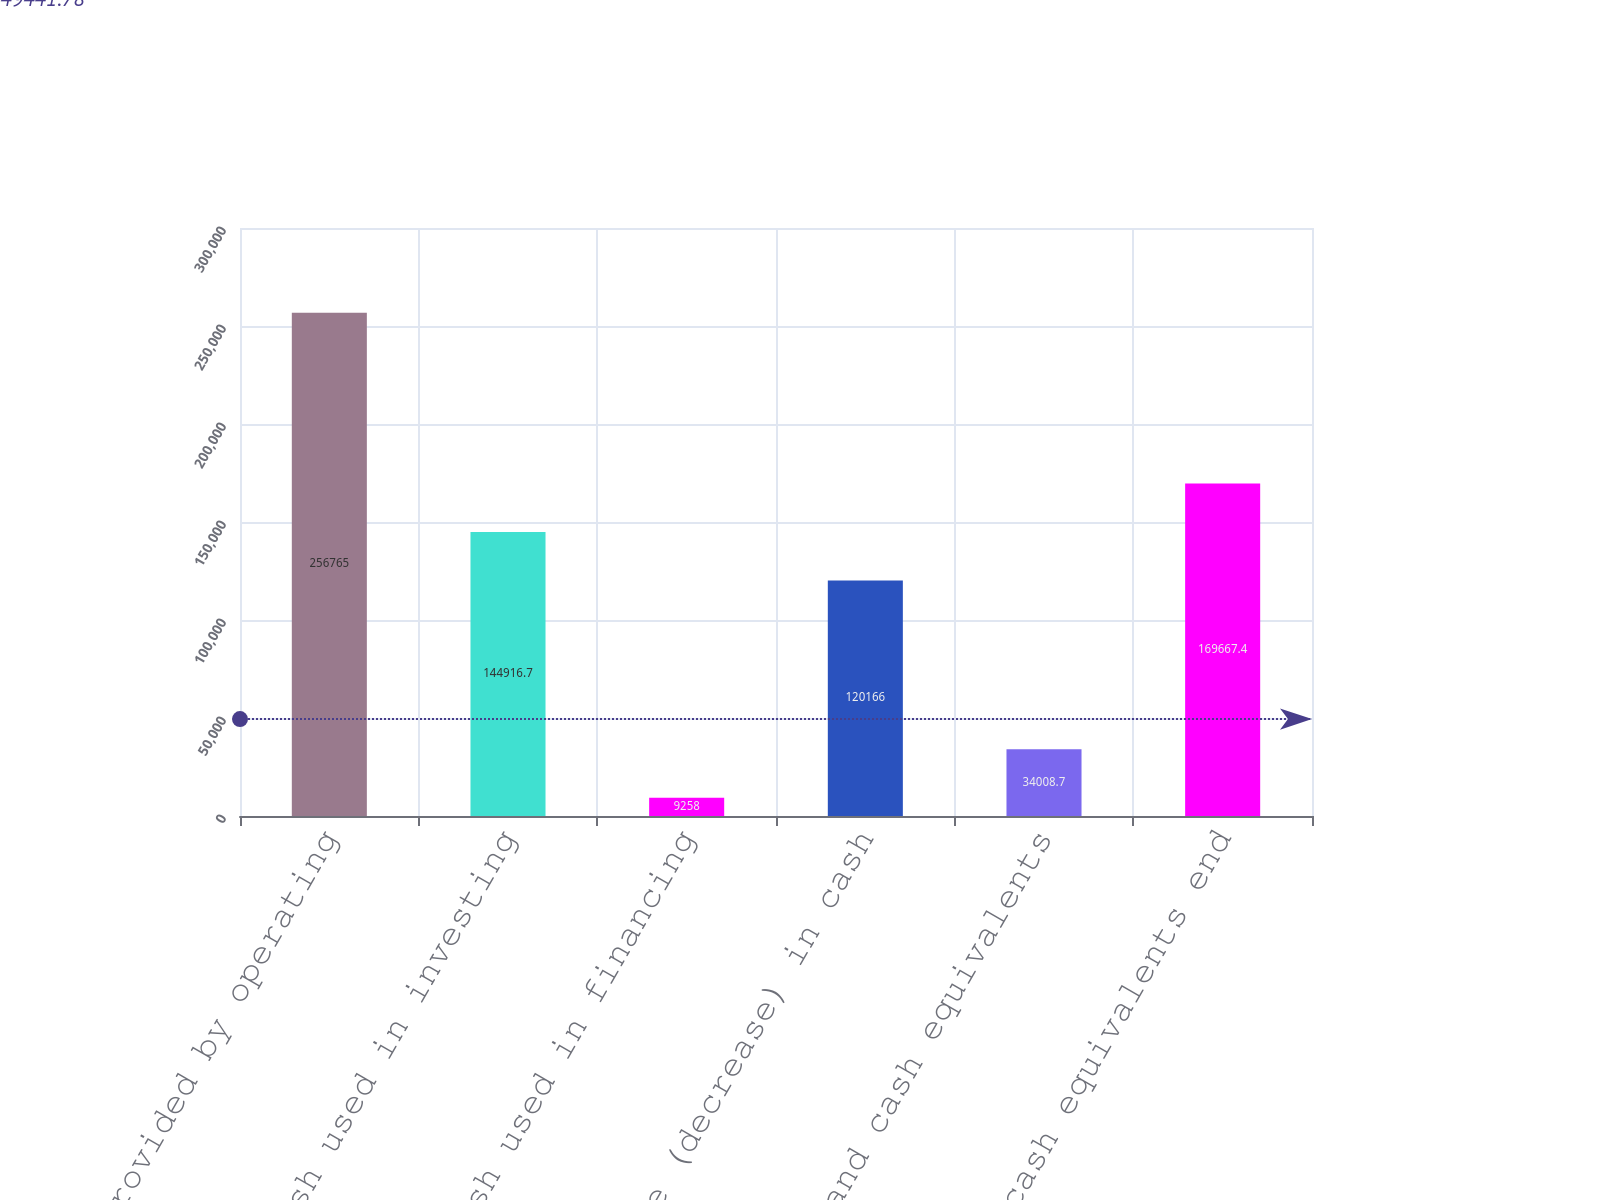Convert chart. <chart><loc_0><loc_0><loc_500><loc_500><bar_chart><fcel>Cash provided by operating<fcel>Cash used in investing<fcel>Cash used in financing<fcel>Increase (decrease) in cash<fcel>Cash and cash equivalents<fcel>Cash and cash equivalents end<nl><fcel>256765<fcel>144917<fcel>9258<fcel>120166<fcel>34008.7<fcel>169667<nl></chart> 